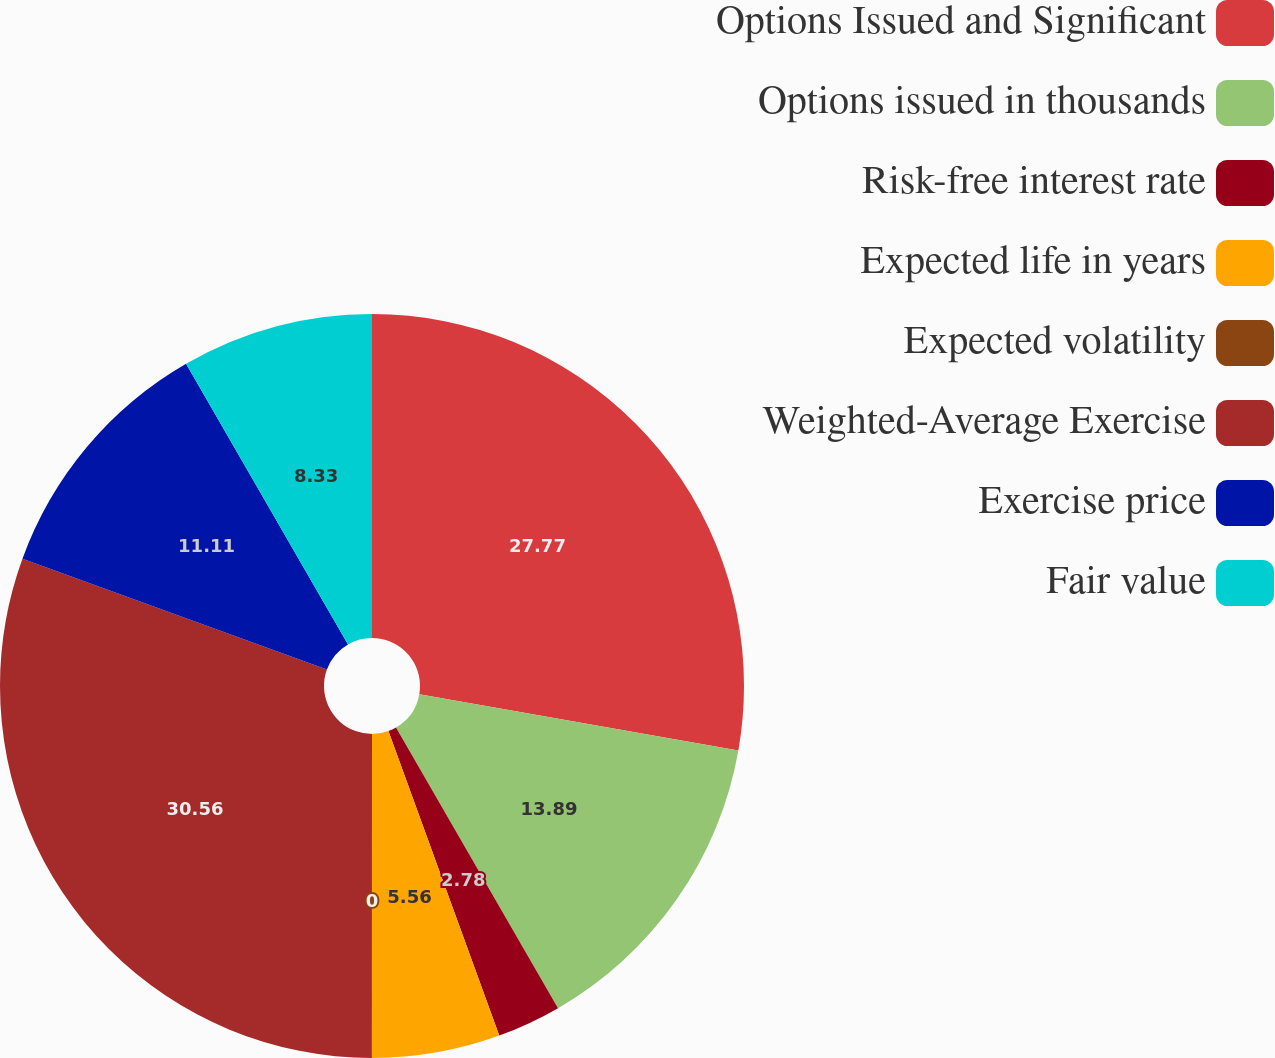<chart> <loc_0><loc_0><loc_500><loc_500><pie_chart><fcel>Options Issued and Significant<fcel>Options issued in thousands<fcel>Risk-free interest rate<fcel>Expected life in years<fcel>Expected volatility<fcel>Weighted-Average Exercise<fcel>Exercise price<fcel>Fair value<nl><fcel>27.77%<fcel>13.89%<fcel>2.78%<fcel>5.56%<fcel>0.0%<fcel>30.55%<fcel>11.11%<fcel>8.33%<nl></chart> 